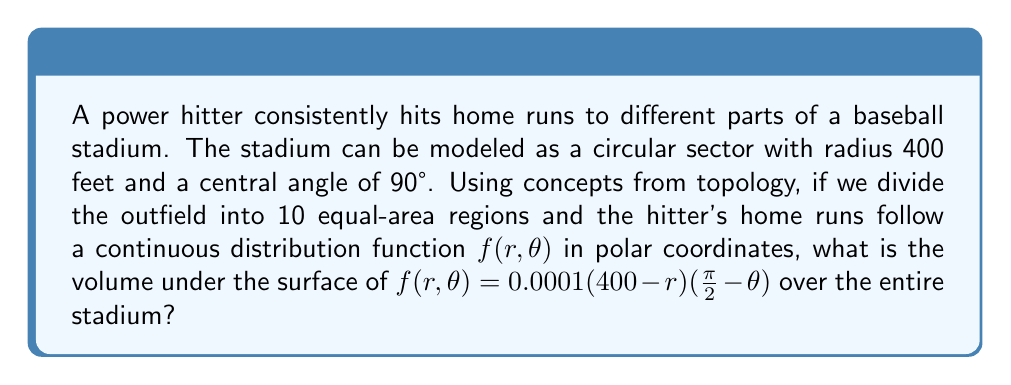Solve this math problem. To solve this problem, we'll use concepts from topology and calculus:

1) First, we need to set up the double integral in polar coordinates to find the volume under the surface of $f(r, \theta)$.

2) The limits of integration are:
   $0 \leq r \leq 400$ (radius of the stadium)
   $0 \leq \theta \leq \frac{\pi}{2}$ (90° in radians)

3) The double integral in polar coordinates is:

   $$V = \int_{0}^{\frac{\pi}{2}} \int_{0}^{400} f(r,\theta) \cdot r \, dr \, d\theta$$

4) Substituting our function:

   $$V = \int_{0}^{\frac{\pi}{2}} \int_{0}^{400} 0.0001(400-r)(\frac{\pi}{2}-\theta) \cdot r \, dr \, d\theta$$

5) Let's solve the inner integral first:

   $$\int_{0}^{400} 0.0001(400-r)(\frac{\pi}{2}-\theta) \cdot r \, dr$$
   
   $$= 0.0001(\frac{\pi}{2}-\theta) \int_{0}^{400} (400r-r^2) \, dr$$
   
   $$= 0.0001(\frac{\pi}{2}-\theta) [200r^2 - \frac{r^3}{3}]_{0}^{400}$$
   
   $$= 0.0001(\frac{\pi}{2}-\theta) (32,000,000 - 21,333,333.33)$$
   
   $$= 1066.67(\frac{\pi}{2}-\theta)$$

6) Now for the outer integral:

   $$V = \int_{0}^{\frac{\pi}{2}} 1066.67(\frac{\pi}{2}-\theta) \, d\theta$$
   
   $$= 1066.67[\frac{\pi}{2}\theta - \frac{\theta^2}{2}]_{0}^{\frac{\pi}{2}}$$
   
   $$= 1066.67[\frac{\pi^2}{4} - \frac{\pi^2}{8}]$$
   
   $$= 1066.67 \cdot \frac{\pi^2}{8}$$

7) Calculating the final result:

   $$V = 1066.67 \cdot \frac{\pi^2}{8} \approx 1315.89$$
Answer: The volume under the surface of $f(r, \theta) = 0.0001(400-r)(\frac{\pi}{2}-\theta)$ over the entire stadium is approximately 1315.89 cubic units. 